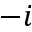Convert formula to latex. <formula><loc_0><loc_0><loc_500><loc_500>- i</formula> 